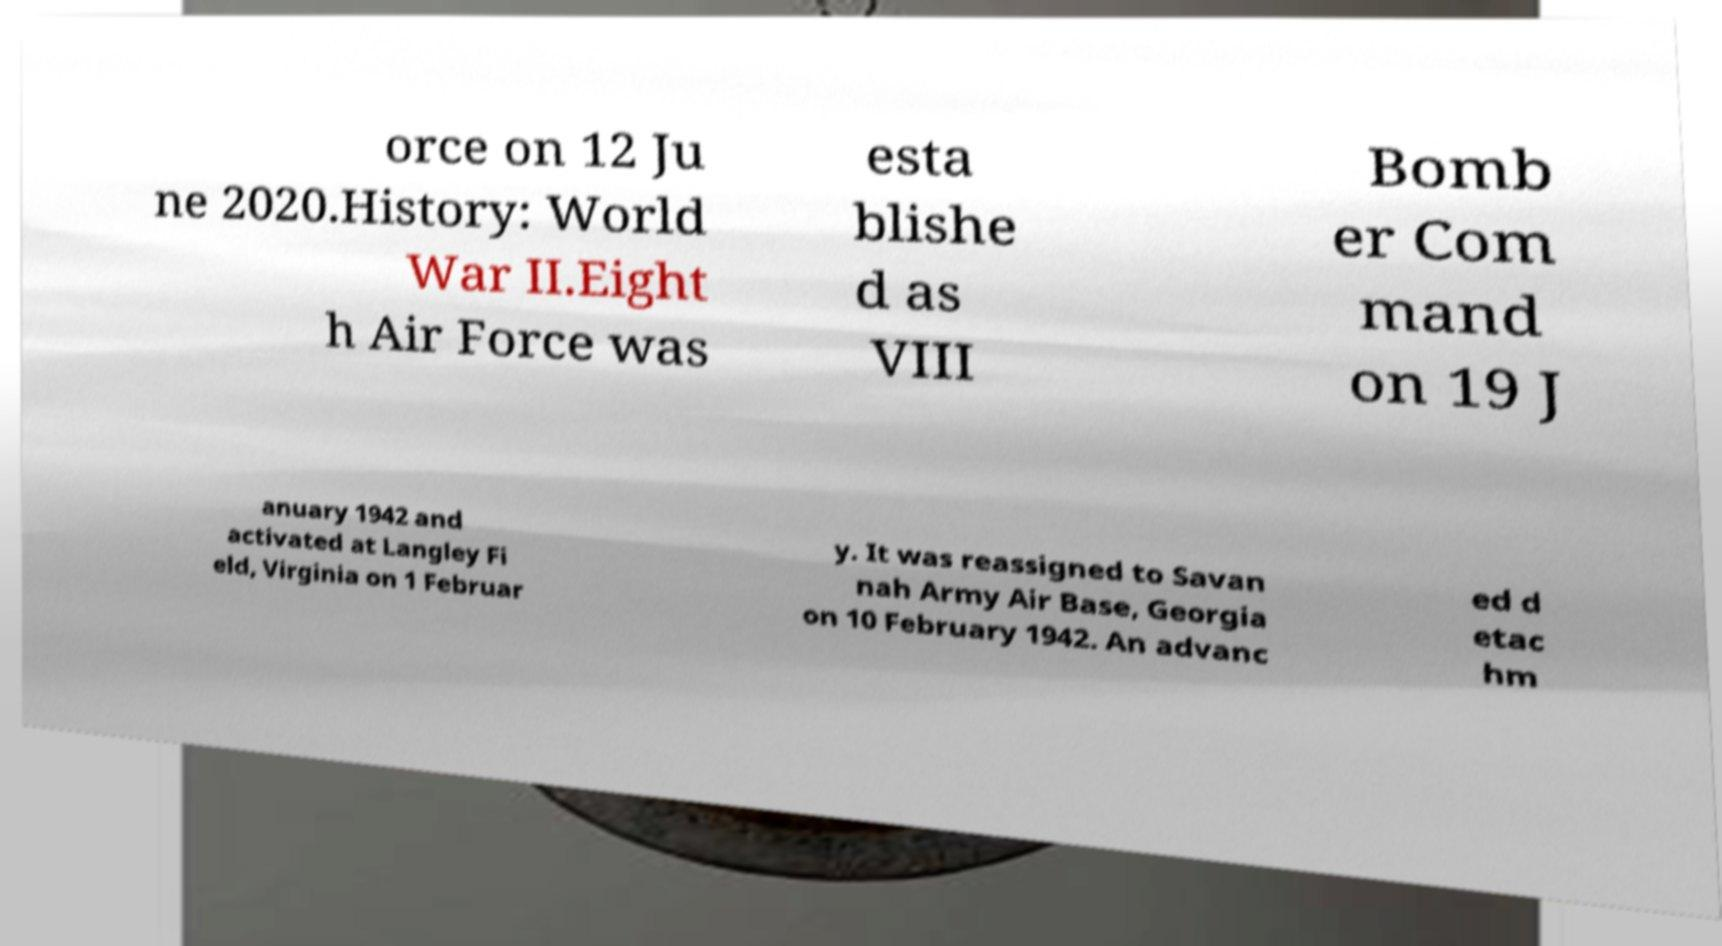Please identify and transcribe the text found in this image. orce on 12 Ju ne 2020.History: World War II.Eight h Air Force was esta blishe d as VIII Bomb er Com mand on 19 J anuary 1942 and activated at Langley Fi eld, Virginia on 1 Februar y. It was reassigned to Savan nah Army Air Base, Georgia on 10 February 1942. An advanc ed d etac hm 